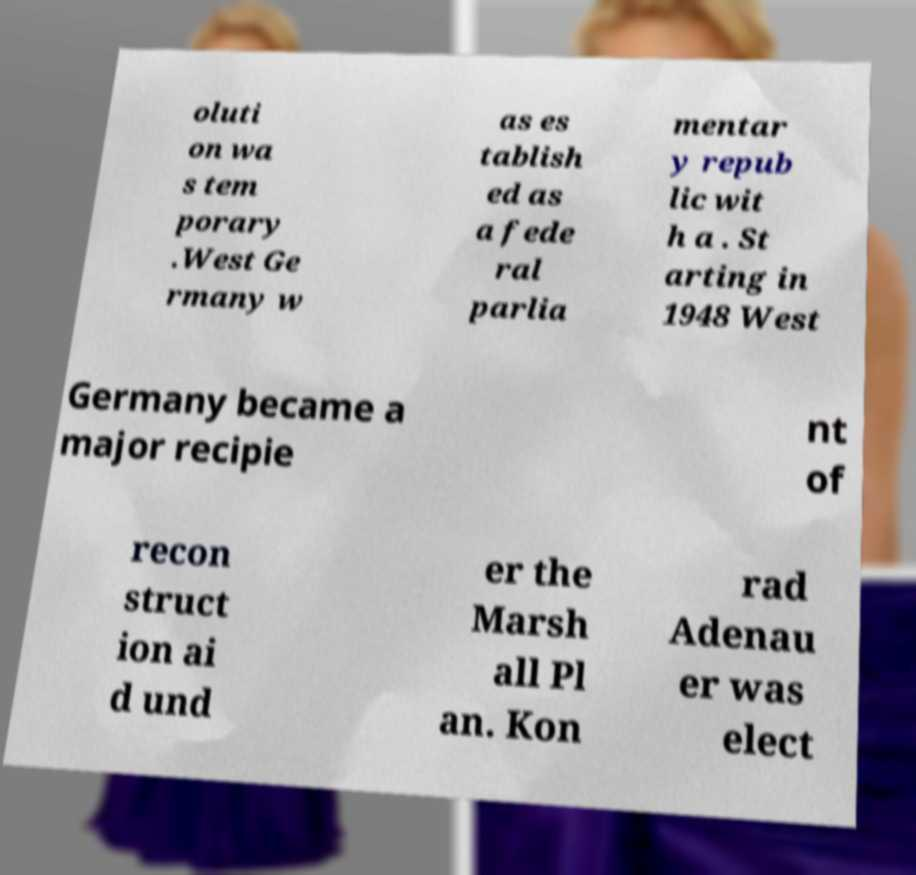What messages or text are displayed in this image? I need them in a readable, typed format. oluti on wa s tem porary .West Ge rmany w as es tablish ed as a fede ral parlia mentar y repub lic wit h a . St arting in 1948 West Germany became a major recipie nt of recon struct ion ai d und er the Marsh all Pl an. Kon rad Adenau er was elect 